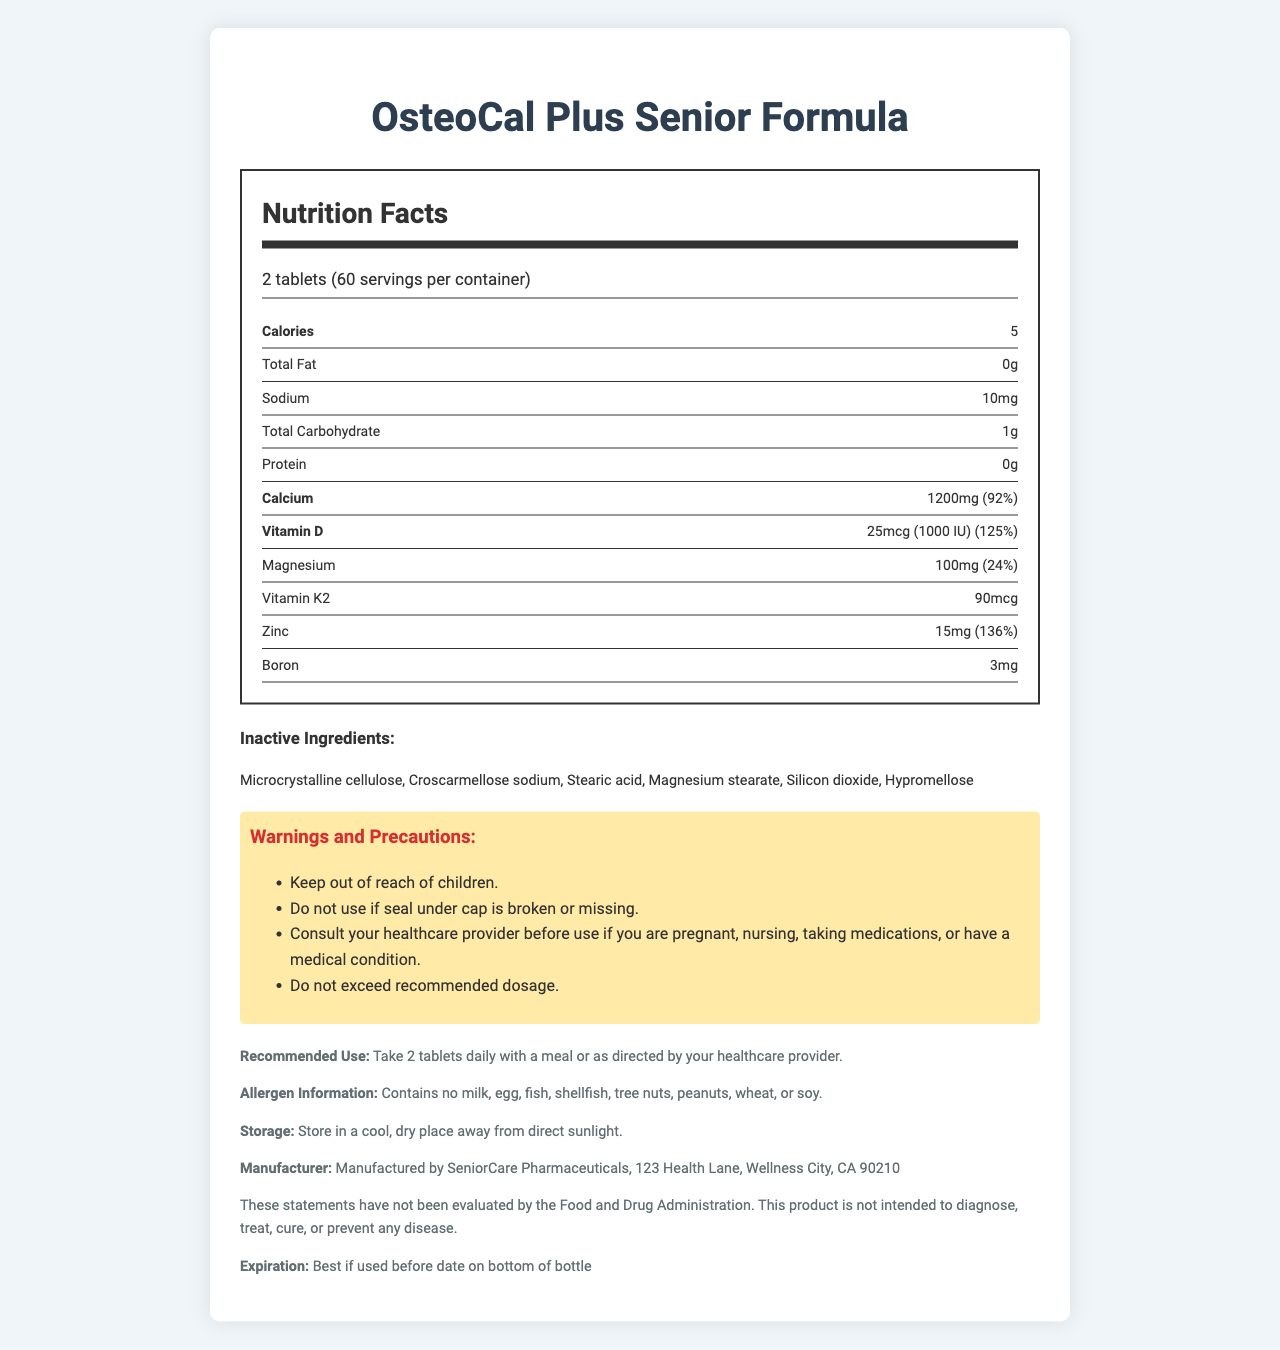what is the serving size for the OsteoCal Plus Senior Formula? The serving size is clearly stated as "2 tablets" under the Nutrition Facts label.
Answer: 2 tablets how many tablets are in the entire container? Given that the serving size is 2 tablets and there are 60 servings per container, multiplying these gives 120 tablets.
Answer: 120 tablets how much Calcium is present per serving? The amount of calcium per serving is explicitly listed as "1200mg" under the nutrient information.
Answer: 1200 mg what percentage of the daily value of Vitamin D is provided per serving? The percentage daily value for Vitamin D per serving is shown as "125%" in the nutrient information.
Answer: 125% list three inactive ingredients in this supplement? Inactive ingredients are listed as "Microcrystalline cellulose, Croscarmellose sodium, Stearic acid, Magnesium stearate, Silicon dioxide, Hypromellose".
Answer: Microcrystalline cellulose, Stearic acid, Hypromellose how many calories are in each serving of the supplement? The document indicates that there are 5 calories per serving.
Answer: 5 calories which mineral has the highest daily value percentage per serving? A. Calcium B. Magnesium C. Zinc D. Boron According to the nutrient information, Zinc has a daily value percentage of 136%, higher than Calcium (92%), Magnesium (24%), and no percentage for Boron.
Answer: C. Zinc which of the following allergens are present in OsteoCal Plus Senior Formula? A. Milk B. Fish C. Tree nuts D. None The allergen information clearly states "Contains no milk, egg, fish, shellfish, tree nuts, peanuts, wheat, or soy."
Answer: D. None is this supplement suitable for vegetarians? The document indicates in the additional information section that the product is vegetarian.
Answer: Yes are there any warnings for pregnant or nursing women? The warnings and precautions section advises consulting a healthcare provider before use if you are pregnant, nursing, taking medications, or have a medical condition.
Answer: Yes summarize the main idea of the document The main idea focuses on providing comprehensive information about the OsteoCal Plus Senior Formula’s nutritional content, usage instructions, and suitability for specific dietary restrictions to help consumers make informed decisions.
Answer: OsteoCal Plus Senior Formula is a calcium supplement designed for seniors with osteoporosis. The document details the nutrition facts, including the amounts of various vitamins and minerals per serving, inactive ingredients, allergen information, storage instructions, manufacturer information, and warnings and precautions for use. It highlights the product's suitability for vegetarians, as well as its gluten-free and non-GMO attributes. where is SeniorCare Pharmaceuticals located? The manufacturer's information is listed under the additional info section: "Manufactured by SeniorCare Pharmaceuticals, 123 Health Lane, Wellness City, CA 90210".
Answer: 123 Health Lane, Wellness City, CA 90210 does this product contain gluten? The additional information section specifies that the product is gluten-free.
Answer: No what is the expiration date of this supplement? The document instructs users to check the bottom of the bottle for the expiration date, which is not visually present in the document itself.
Answer: Cannot be determined 